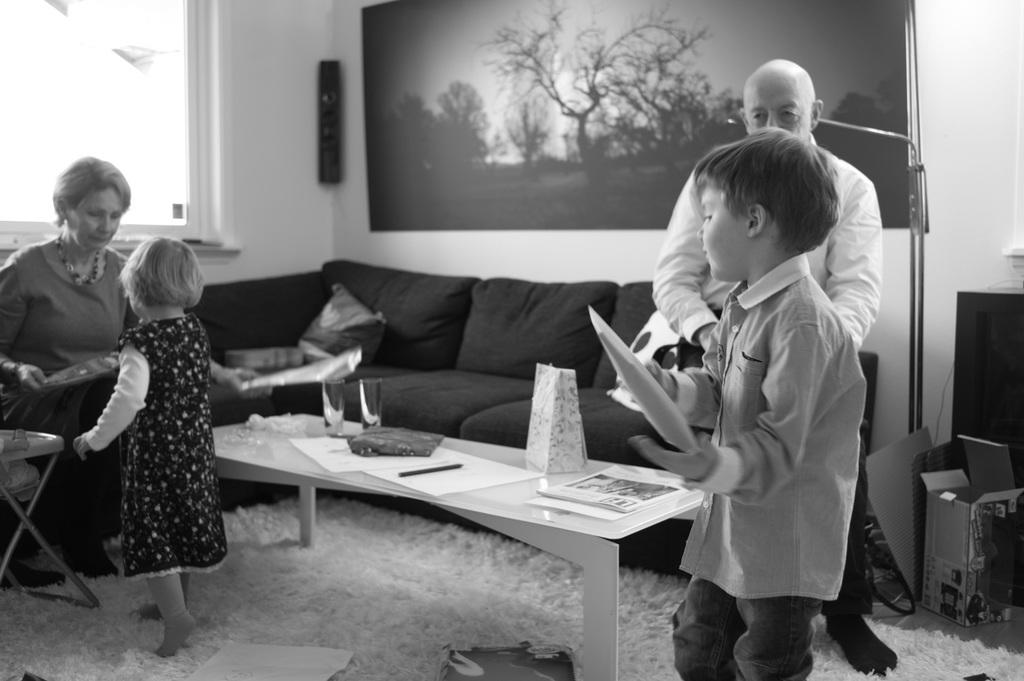How many adults are in the image? There are two adults in the image, a woman and a man. How many children are in the image? There are two children in the image, a boy and a girl. What is in front of the people in the image? There is a table in front of the people in the image. What can be seen on the wall in the image? There is an architectural design or artwork on the wall in the image. What type of wound can be seen on the rat in the image? There is no rat present in the image, and therefore no wound can be observed. 